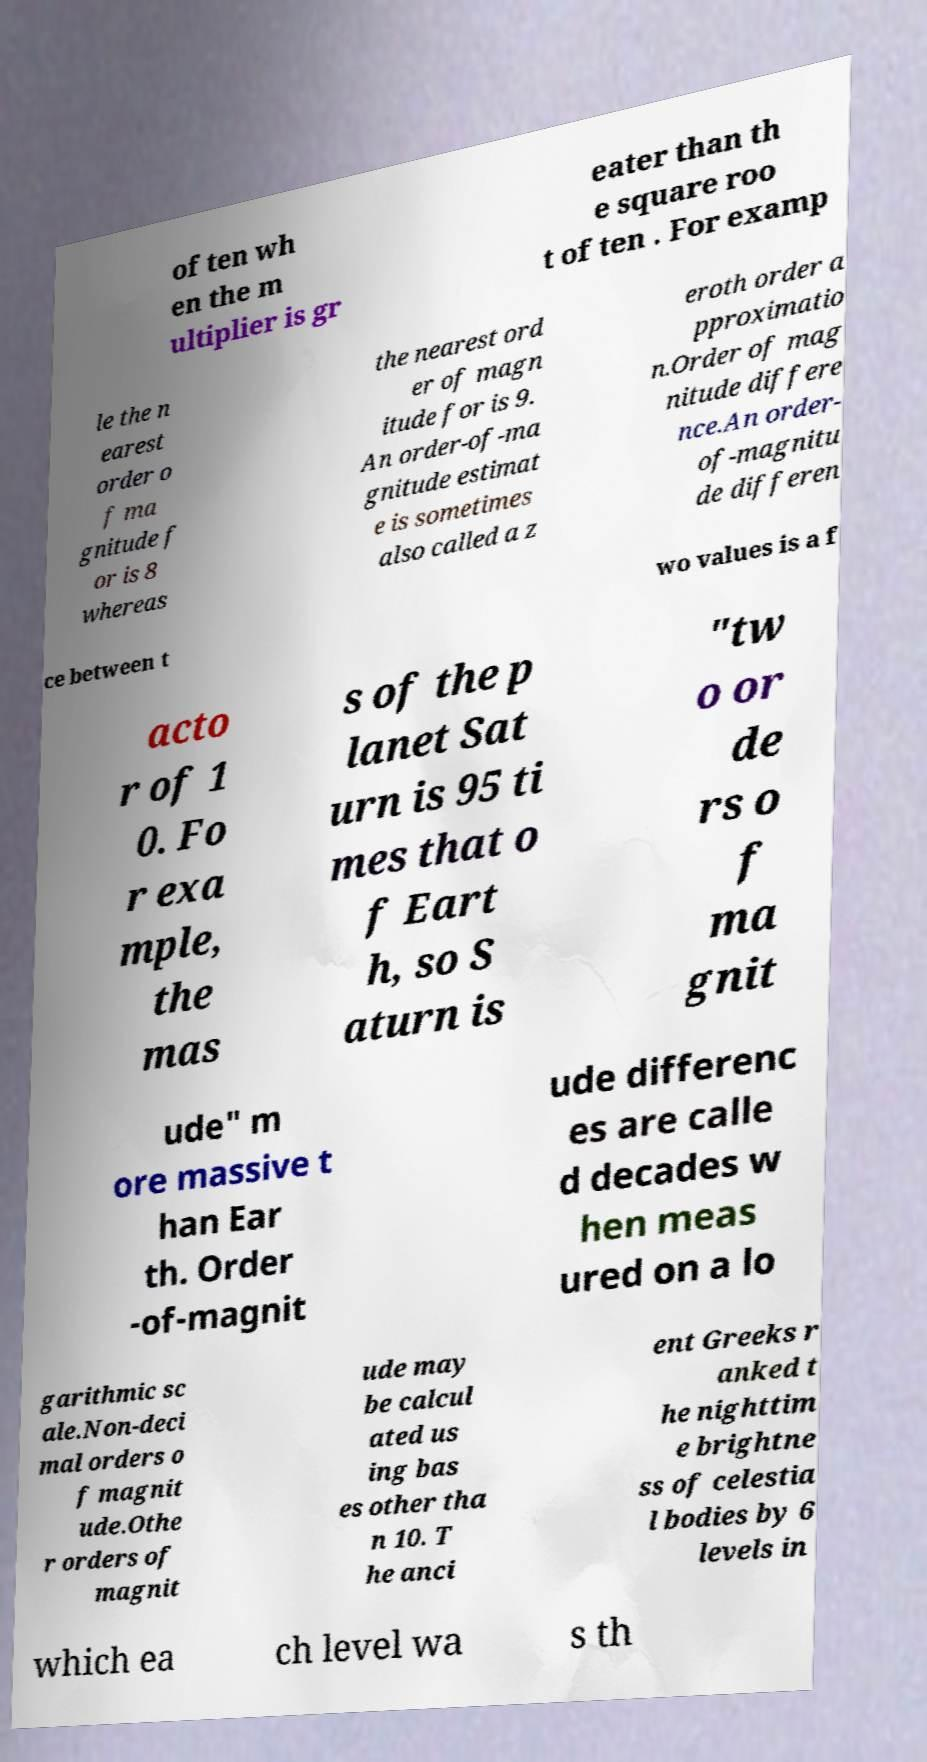What messages or text are displayed in this image? I need them in a readable, typed format. of ten wh en the m ultiplier is gr eater than th e square roo t of ten . For examp le the n earest order o f ma gnitude f or is 8 whereas the nearest ord er of magn itude for is 9. An order-of-ma gnitude estimat e is sometimes also called a z eroth order a pproximatio n.Order of mag nitude differe nce.An order- of-magnitu de differen ce between t wo values is a f acto r of 1 0. Fo r exa mple, the mas s of the p lanet Sat urn is 95 ti mes that o f Eart h, so S aturn is "tw o or de rs o f ma gnit ude" m ore massive t han Ear th. Order -of-magnit ude differenc es are calle d decades w hen meas ured on a lo garithmic sc ale.Non-deci mal orders o f magnit ude.Othe r orders of magnit ude may be calcul ated us ing bas es other tha n 10. T he anci ent Greeks r anked t he nighttim e brightne ss of celestia l bodies by 6 levels in which ea ch level wa s th 